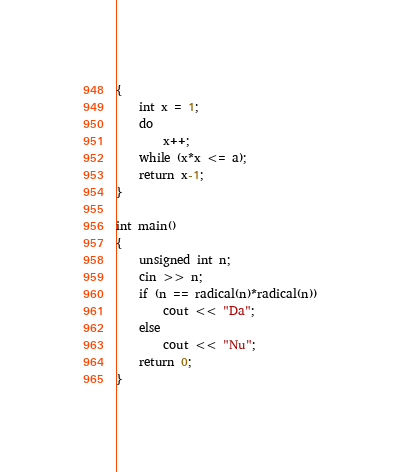Convert code to text. <code><loc_0><loc_0><loc_500><loc_500><_C++_>{
	int x = 1;
	do
		x++;
	while (x*x <= a);
	return x-1;
}

int main()
{
	unsigned int n;
	cin >> n;
	if (n == radical(n)*radical(n))
		cout << "Da";
	else
		cout << "Nu";
	return 0;
}</code> 